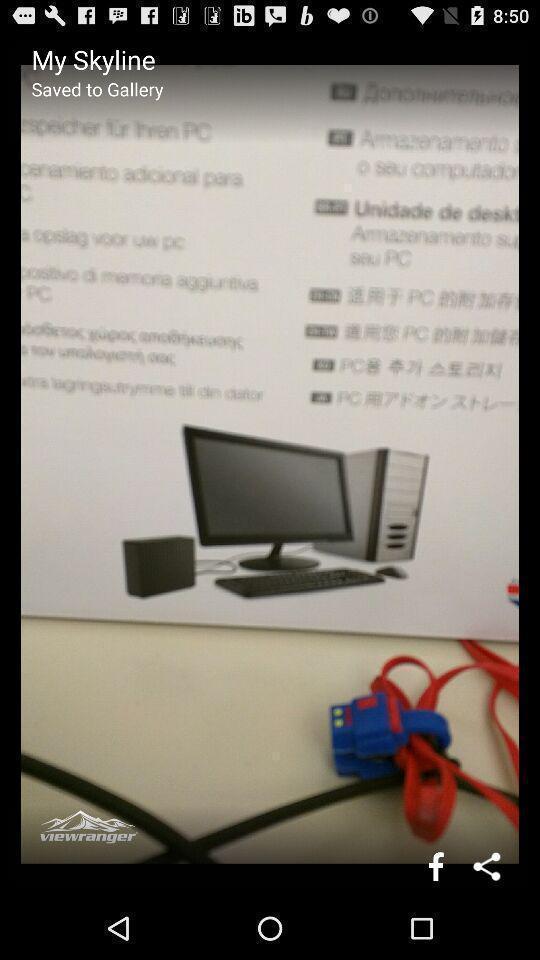Summarize the main components in this picture. Screen showing an image with share option. 